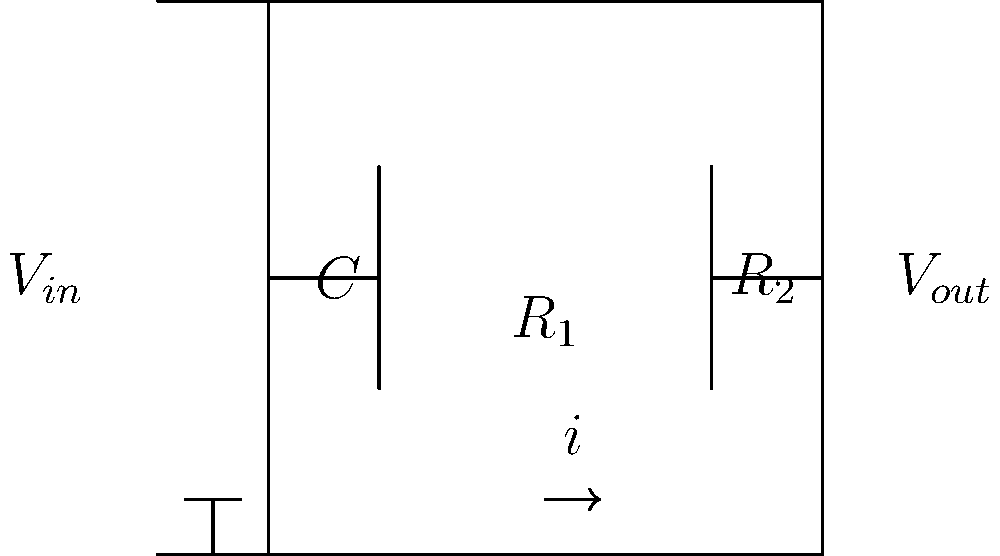In a biosensor circuit designed for genetic testing, a high-pass filter is used to process the signal from a DNA probe. The circuit consists of a resistor $R_1$ in parallel with a capacitor $C$, followed by a resistor $R_2$ in series. If $R_1 = 100 \text{ k}\Omega$, $R_2 = 50 \text{ k}\Omega$, and $C = 10 \text{ nF}$, what is the cutoff frequency of this high-pass filter in Hz? To find the cutoff frequency of this high-pass filter, we can follow these steps:

1) The general formula for the cutoff frequency of a high-pass filter is:

   $$f_c = \frac{1}{2\pi RC}$$

2) In this circuit, the effective resistance for the cutoff frequency calculation is $R_1$, as it's in parallel with the capacitor.

3) Substituting the given values:
   $R = R_1 = 100 \text{ k}\Omega = 100,000 \Omega$
   $C = 10 \text{ nF} = 10 \times 10^{-9} \text{ F}$

4) Now, let's calculate:

   $$f_c = \frac{1}{2\pi (100,000)(10 \times 10^{-9})}$$

5) Simplify:
   
   $$f_c = \frac{1}{2\pi (1 \times 10^{-3})}$$

6) Calculate:
   
   $$f_c \approx 159.15 \text{ Hz}$$

7) Rounding to the nearest whole number:

   $$f_c \approx 159 \text{ Hz}$$

This cutoff frequency means that the filter will attenuate signals below 159 Hz, which is useful for removing low-frequency noise in genetic testing applications.
Answer: 159 Hz 